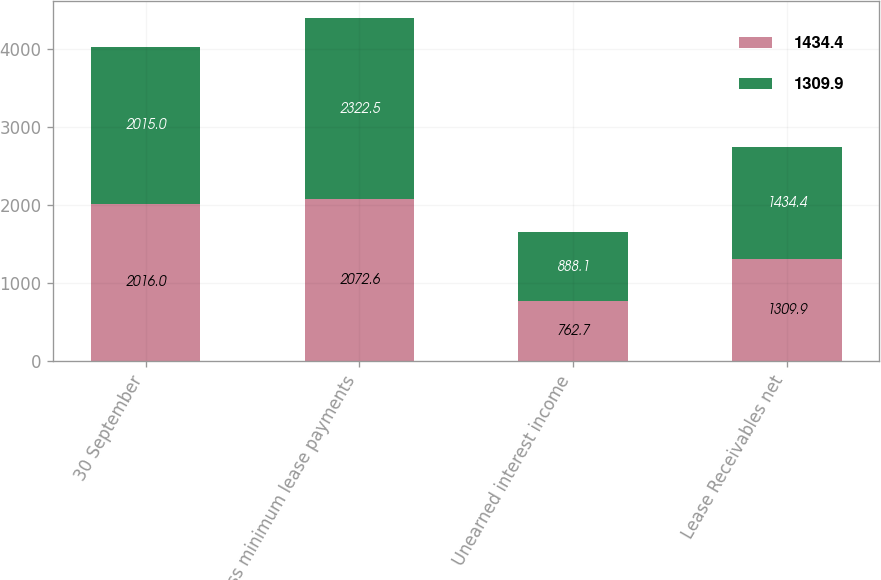Convert chart. <chart><loc_0><loc_0><loc_500><loc_500><stacked_bar_chart><ecel><fcel>30 September<fcel>Gross minimum lease payments<fcel>Unearned interest income<fcel>Lease Receivables net<nl><fcel>1434.4<fcel>2016<fcel>2072.6<fcel>762.7<fcel>1309.9<nl><fcel>1309.9<fcel>2015<fcel>2322.5<fcel>888.1<fcel>1434.4<nl></chart> 